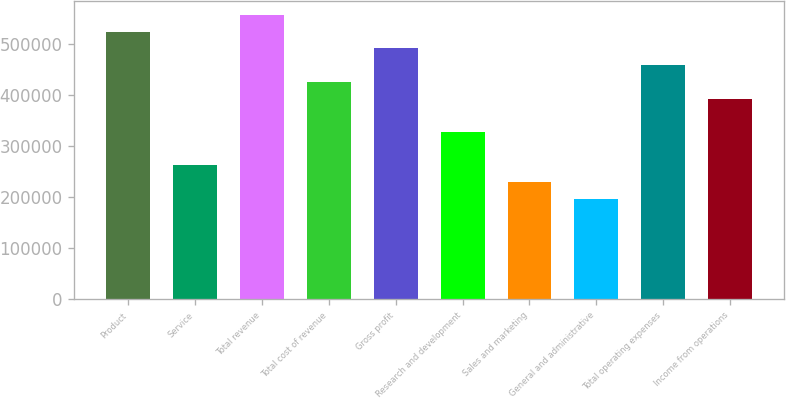Convert chart. <chart><loc_0><loc_0><loc_500><loc_500><bar_chart><fcel>Product<fcel>Service<fcel>Total revenue<fcel>Total cost of revenue<fcel>Gross profit<fcel>Research and development<fcel>Sales and marketing<fcel>General and administrative<fcel>Total operating expenses<fcel>Income from operations<nl><fcel>524750<fcel>262375<fcel>557547<fcel>426359<fcel>491953<fcel>327969<fcel>229579<fcel>196782<fcel>459156<fcel>393563<nl></chart> 